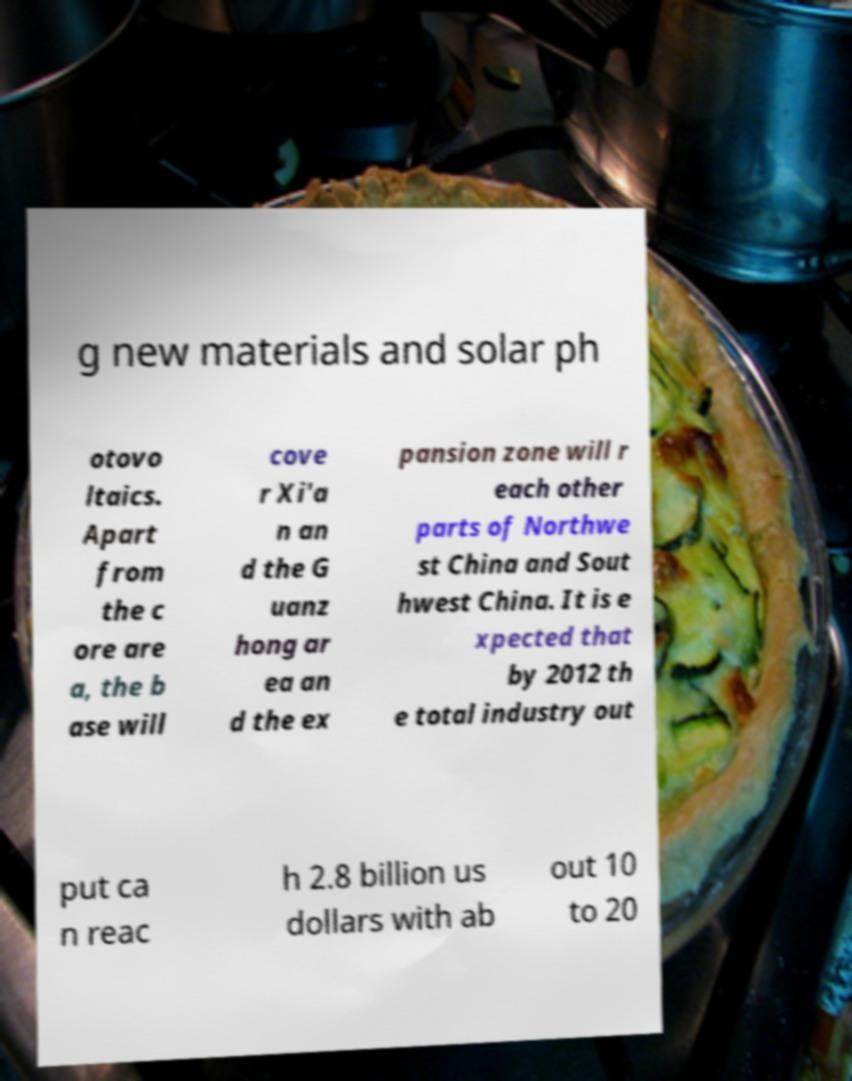What messages or text are displayed in this image? I need them in a readable, typed format. g new materials and solar ph otovo ltaics. Apart from the c ore are a, the b ase will cove r Xi'a n an d the G uanz hong ar ea an d the ex pansion zone will r each other parts of Northwe st China and Sout hwest China. It is e xpected that by 2012 th e total industry out put ca n reac h 2.8 billion us dollars with ab out 10 to 20 